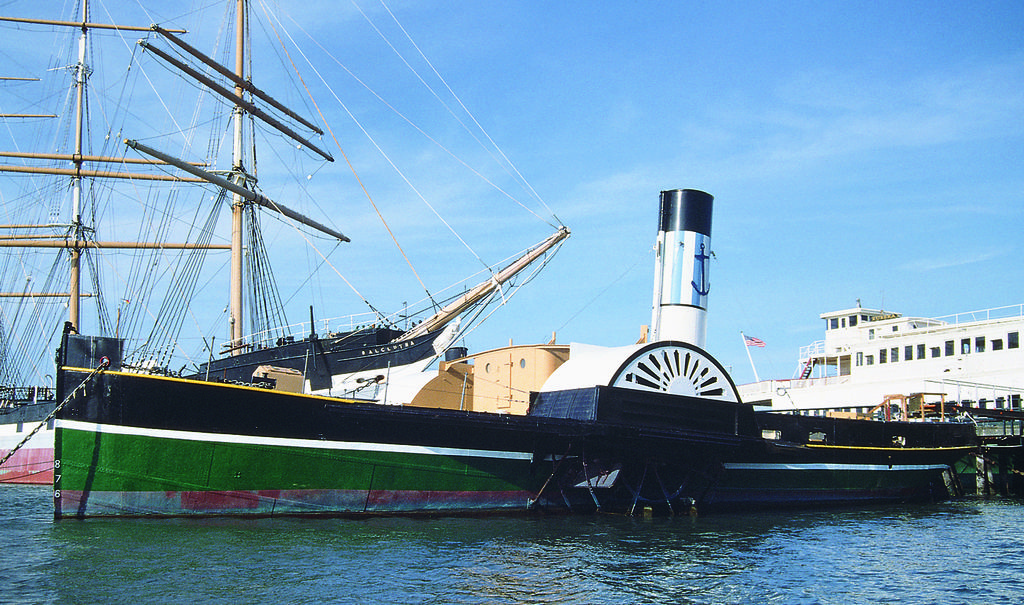What is the main subject in the center of the picture? There are ships in the center of the picture. What can be seen in the foreground of the image? There is water in the foreground of the image. How would you describe the sky in the picture? The sky is clear in the picture. What is the weather like in the image? It is sunny in the image. What type of nose can be seen on the ship in the image? There are no noses present on the ships in the image, as ships do not have noses. What kind of waste management system is visible in the image? There is no waste management system visible in the image; it features ships on water with a clear sky. 